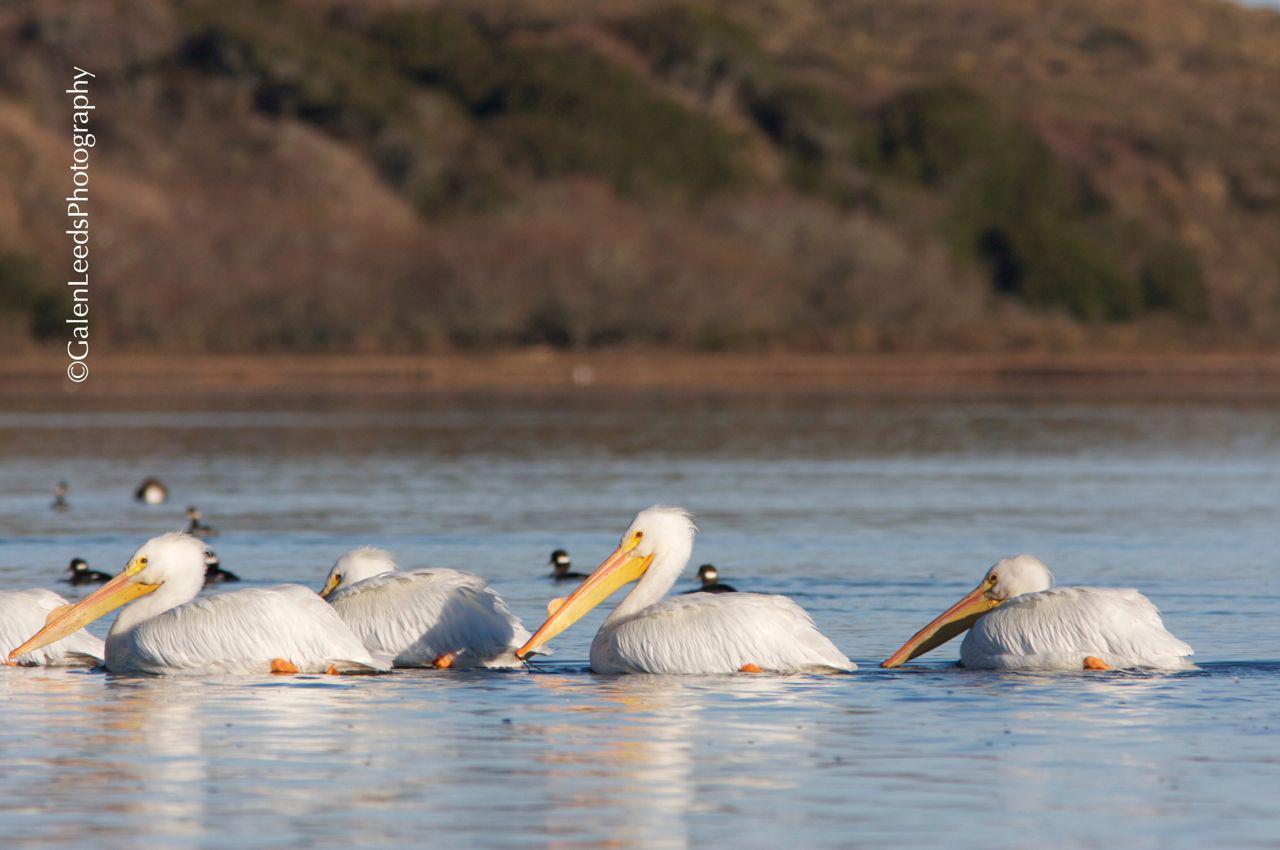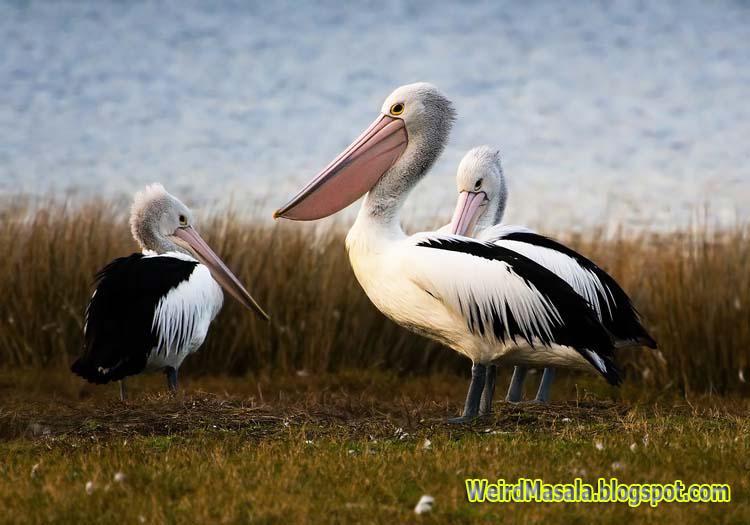The first image is the image on the left, the second image is the image on the right. Evaluate the accuracy of this statement regarding the images: "All the birds in the image on the left are floating on the water.". Is it true? Answer yes or no. Yes. The first image is the image on the left, the second image is the image on the right. Examine the images to the left and right. Is the description "Left image shows left-facing pelicans floating on the water." accurate? Answer yes or no. Yes. 